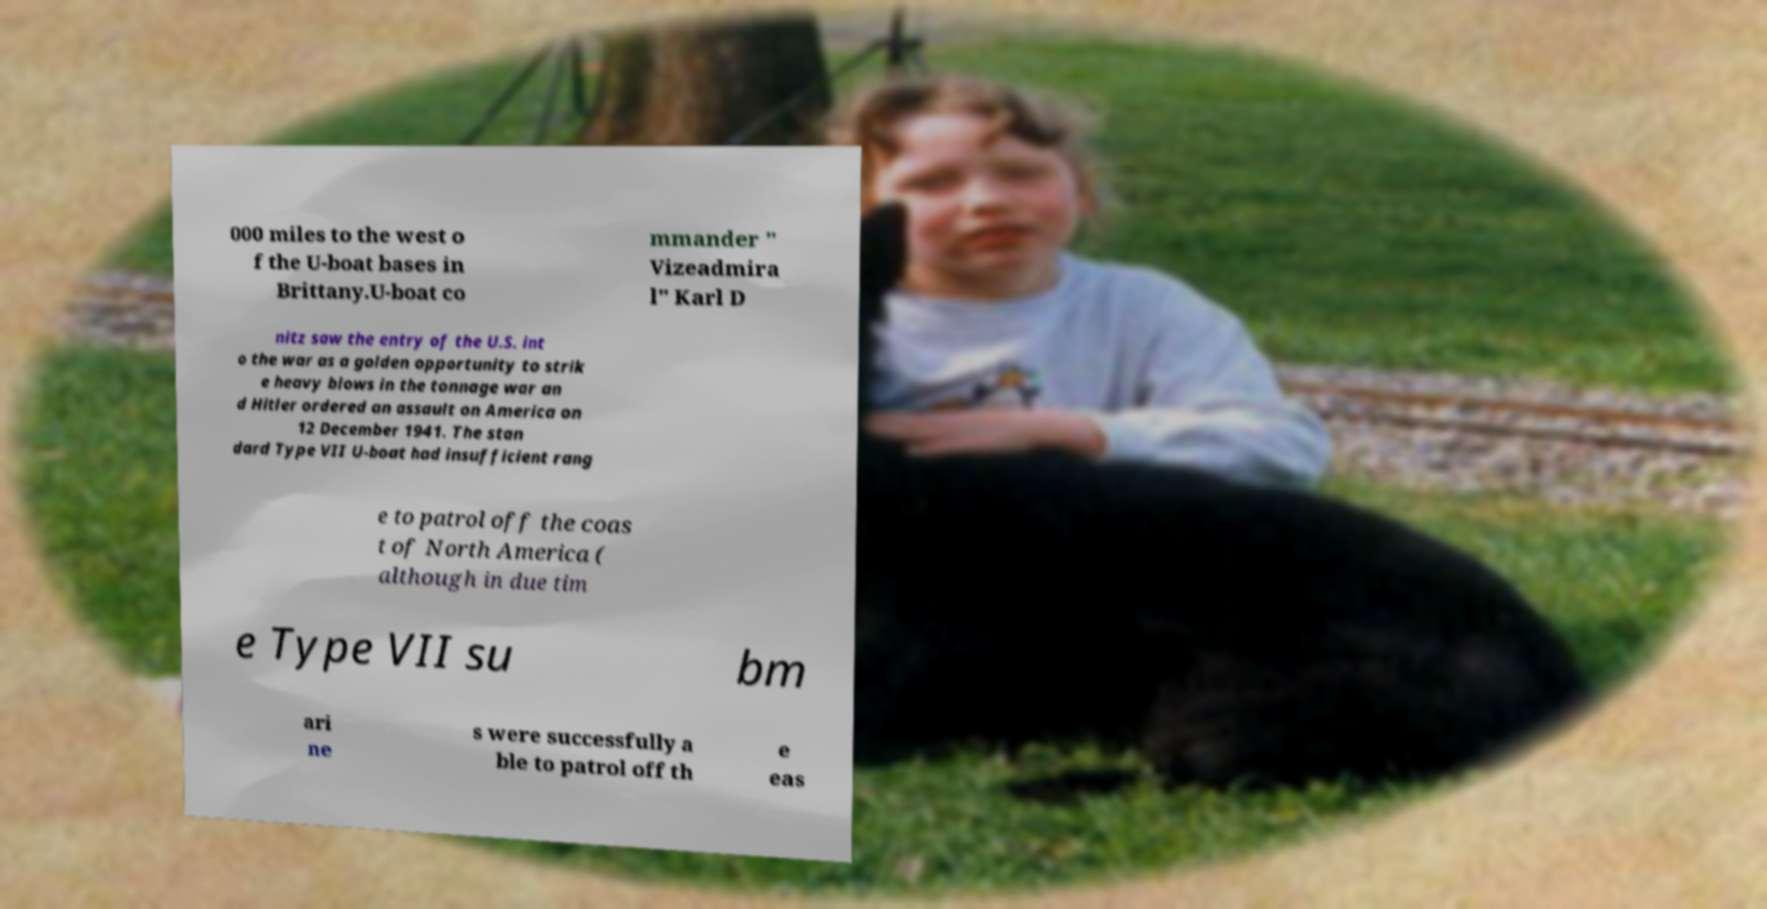Could you extract and type out the text from this image? 000 miles to the west o f the U-boat bases in Brittany.U-boat co mmander " Vizeadmira l" Karl D nitz saw the entry of the U.S. int o the war as a golden opportunity to strik e heavy blows in the tonnage war an d Hitler ordered an assault on America on 12 December 1941. The stan dard Type VII U-boat had insufficient rang e to patrol off the coas t of North America ( although in due tim e Type VII su bm ari ne s were successfully a ble to patrol off th e eas 